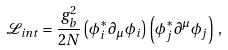<formula> <loc_0><loc_0><loc_500><loc_500>\mathcal { L } _ { i n t } = \frac { g _ { b } ^ { 2 } } { 2 N } \left ( \phi _ { i } ^ { * } \partial _ { \mu } \phi _ { i } \right ) \left ( \phi _ { j } ^ { * } \partial ^ { \mu } \phi _ { j } \right ) \, ,</formula> 